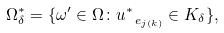Convert formula to latex. <formula><loc_0><loc_0><loc_500><loc_500>\Omega ^ { * } _ { \delta } = \{ \omega ^ { \prime } \in \Omega \colon u ^ { * } _ { \ e _ { j ( k ) } } \in K _ { \delta } \} ,</formula> 